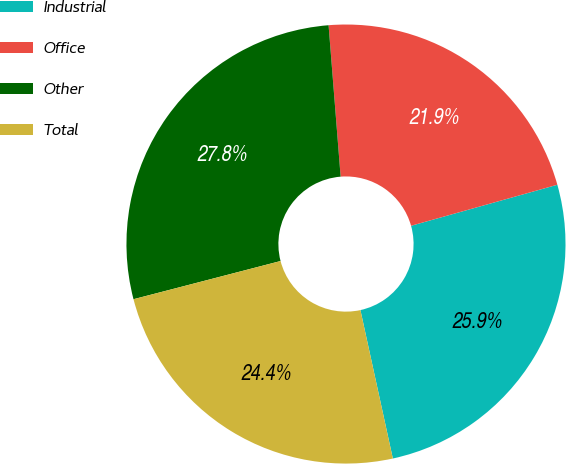Convert chart. <chart><loc_0><loc_0><loc_500><loc_500><pie_chart><fcel>Industrial<fcel>Office<fcel>Other<fcel>Total<nl><fcel>25.93%<fcel>21.91%<fcel>27.78%<fcel>24.38%<nl></chart> 